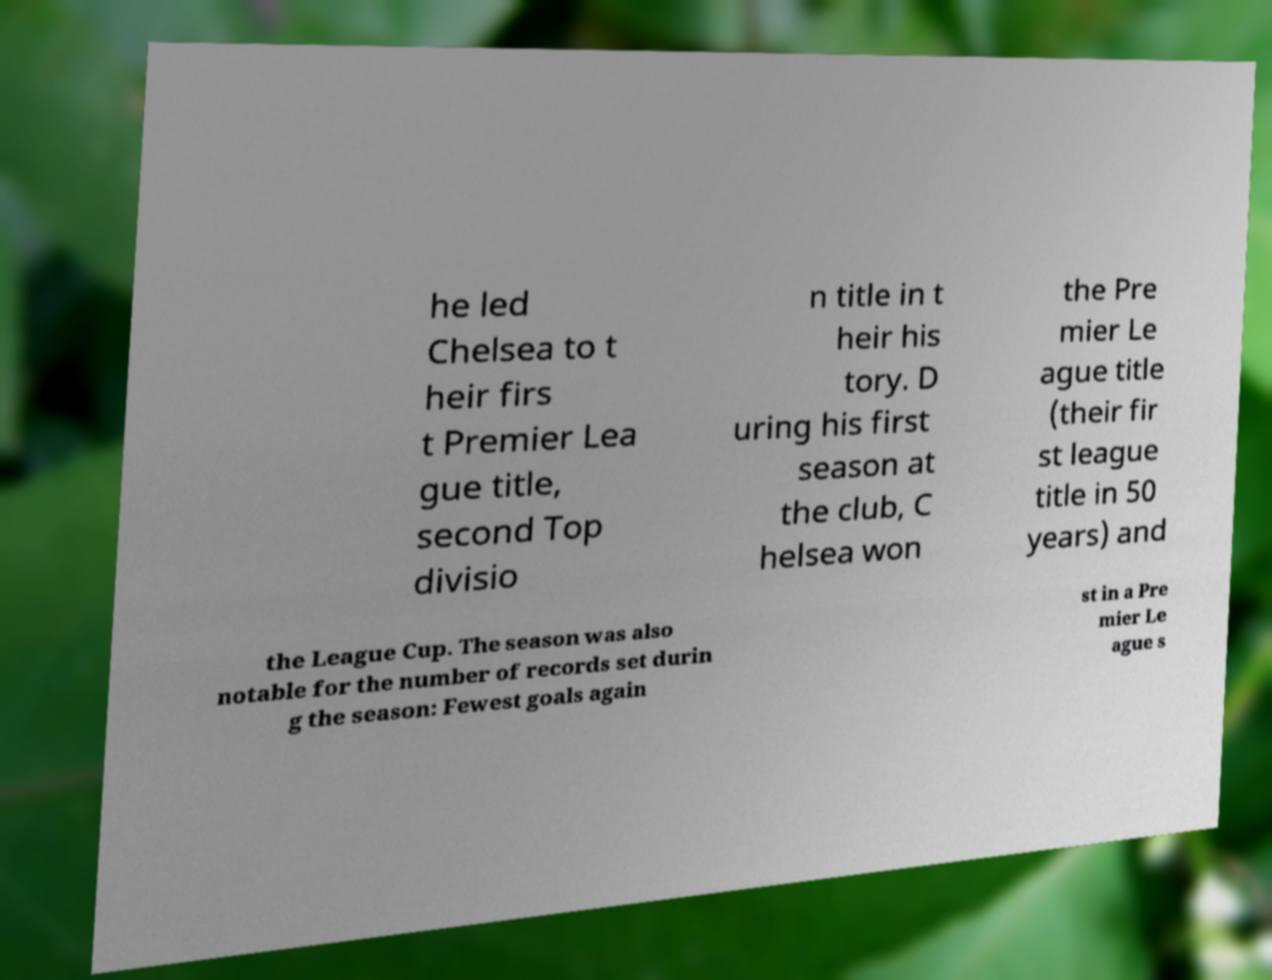What messages or text are displayed in this image? I need them in a readable, typed format. he led Chelsea to t heir firs t Premier Lea gue title, second Top divisio n title in t heir his tory. D uring his first season at the club, C helsea won the Pre mier Le ague title (their fir st league title in 50 years) and the League Cup. The season was also notable for the number of records set durin g the season: Fewest goals again st in a Pre mier Le ague s 